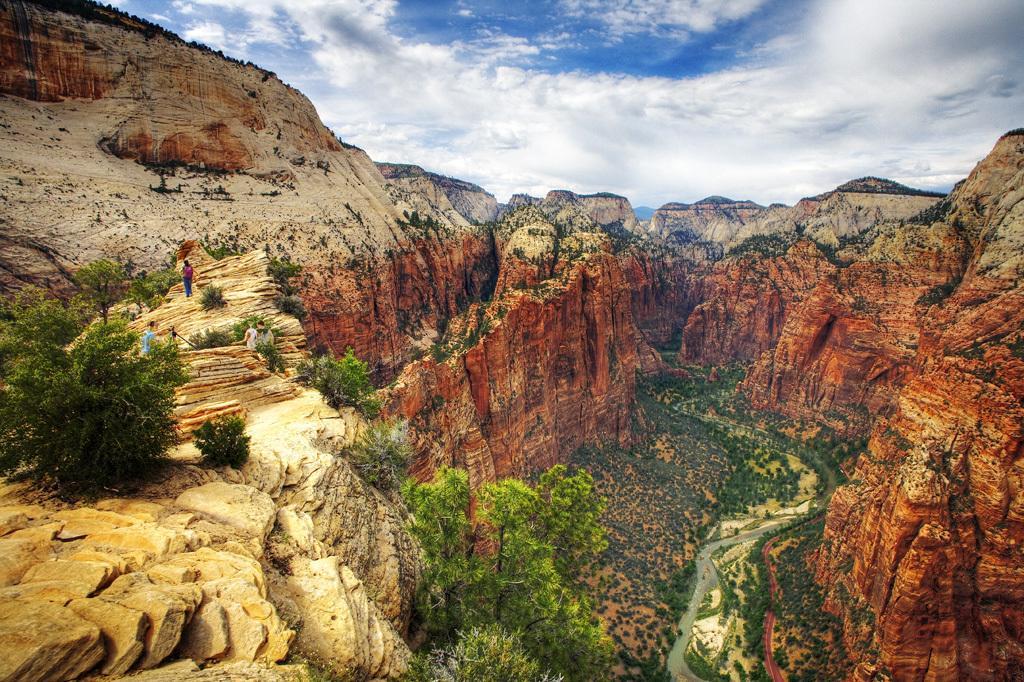Please provide a concise description of this image. The picture consists of a mountain valley. In the center of the picture there are trees and a water body. On the left there are trees, mountains and people. On the right there are mountains. 